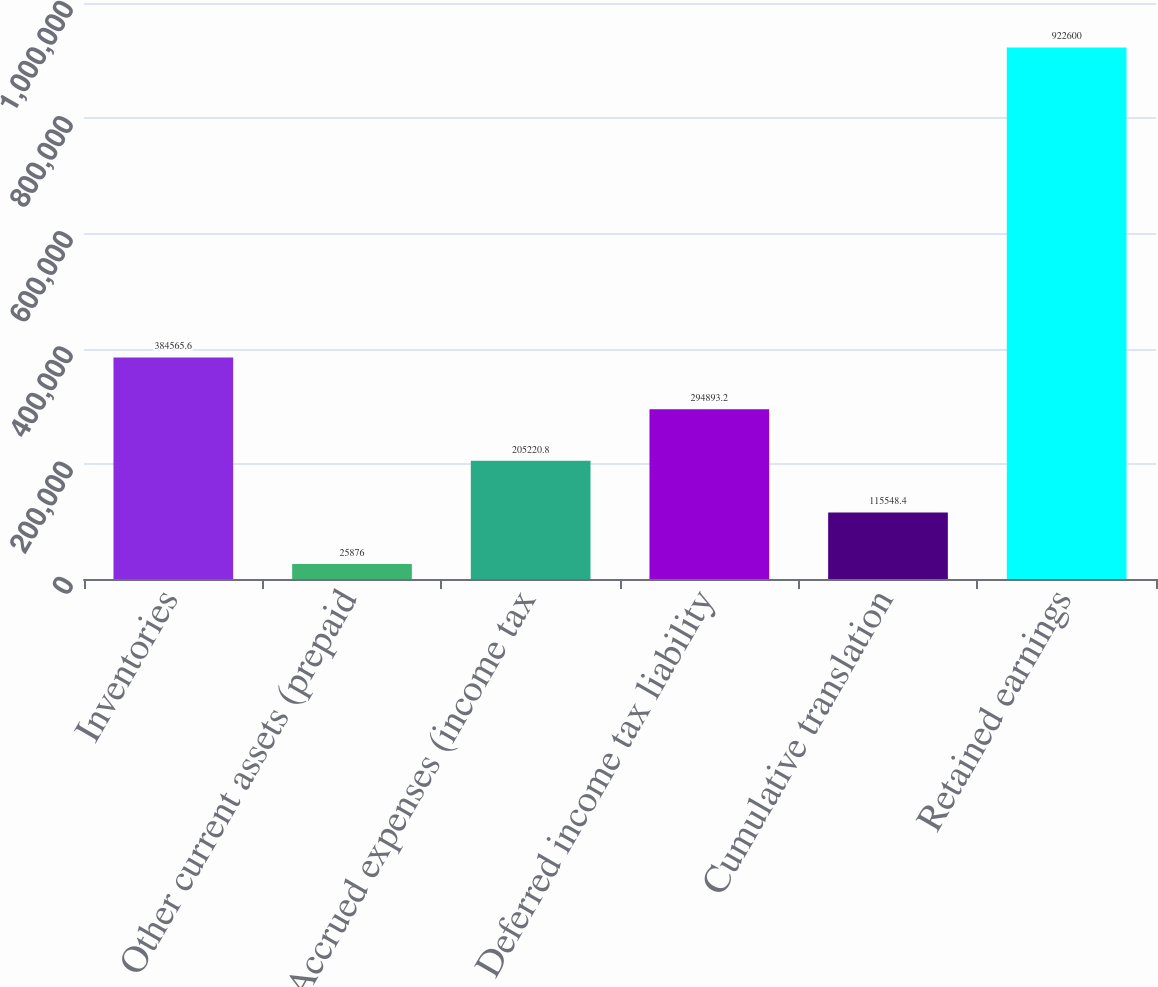<chart> <loc_0><loc_0><loc_500><loc_500><bar_chart><fcel>Inventories<fcel>Other current assets (prepaid<fcel>Accrued expenses (income tax<fcel>Deferred income tax liability<fcel>Cumulative translation<fcel>Retained earnings<nl><fcel>384566<fcel>25876<fcel>205221<fcel>294893<fcel>115548<fcel>922600<nl></chart> 